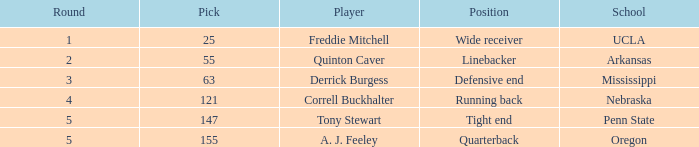Which player was chosen with the 147th pick? Tony Stewart. 